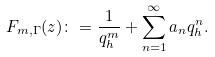<formula> <loc_0><loc_0><loc_500><loc_500>F _ { m , \Gamma } ( z ) \colon = \frac { 1 } { q _ { h } ^ { m } } + \sum _ { n = 1 } ^ { \infty } a _ { n } q _ { h } ^ { n } .</formula> 